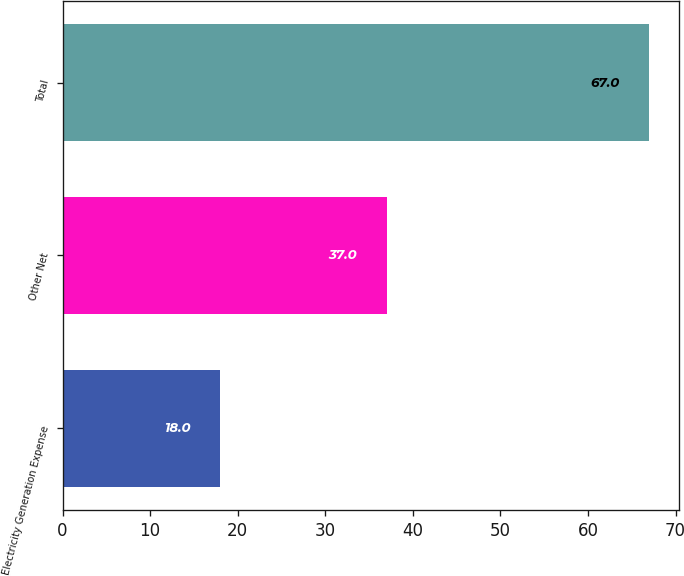Convert chart to OTSL. <chart><loc_0><loc_0><loc_500><loc_500><bar_chart><fcel>Electricity Generation Expense<fcel>Other Net<fcel>Total<nl><fcel>18<fcel>37<fcel>67<nl></chart> 